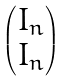<formula> <loc_0><loc_0><loc_500><loc_500>\begin{pmatrix} I _ { n } \\ I _ { n } \end{pmatrix}</formula> 